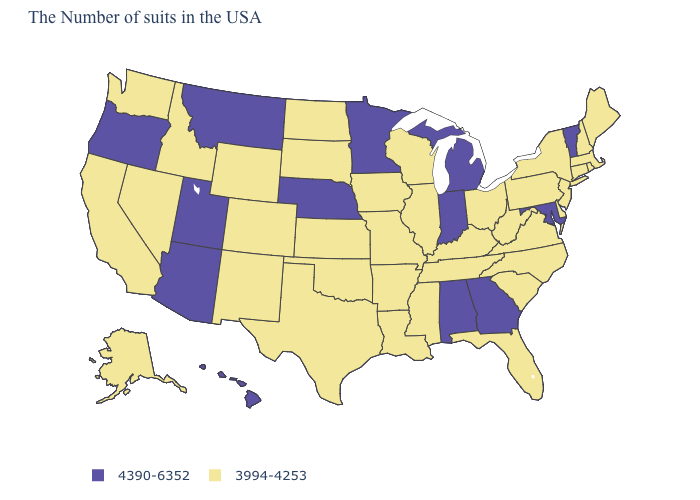Among the states that border Georgia , does Tennessee have the lowest value?
Answer briefly. Yes. Name the states that have a value in the range 3994-4253?
Be succinct. Maine, Massachusetts, Rhode Island, New Hampshire, Connecticut, New York, New Jersey, Delaware, Pennsylvania, Virginia, North Carolina, South Carolina, West Virginia, Ohio, Florida, Kentucky, Tennessee, Wisconsin, Illinois, Mississippi, Louisiana, Missouri, Arkansas, Iowa, Kansas, Oklahoma, Texas, South Dakota, North Dakota, Wyoming, Colorado, New Mexico, Idaho, Nevada, California, Washington, Alaska. What is the value of Delaware?
Give a very brief answer. 3994-4253. What is the value of Delaware?
Give a very brief answer. 3994-4253. Does Delaware have a lower value than New Jersey?
Write a very short answer. No. What is the value of Alaska?
Be succinct. 3994-4253. What is the value of Missouri?
Short answer required. 3994-4253. How many symbols are there in the legend?
Quick response, please. 2. Among the states that border New York , which have the highest value?
Give a very brief answer. Vermont. Name the states that have a value in the range 3994-4253?
Quick response, please. Maine, Massachusetts, Rhode Island, New Hampshire, Connecticut, New York, New Jersey, Delaware, Pennsylvania, Virginia, North Carolina, South Carolina, West Virginia, Ohio, Florida, Kentucky, Tennessee, Wisconsin, Illinois, Mississippi, Louisiana, Missouri, Arkansas, Iowa, Kansas, Oklahoma, Texas, South Dakota, North Dakota, Wyoming, Colorado, New Mexico, Idaho, Nevada, California, Washington, Alaska. Name the states that have a value in the range 4390-6352?
Concise answer only. Vermont, Maryland, Georgia, Michigan, Indiana, Alabama, Minnesota, Nebraska, Utah, Montana, Arizona, Oregon, Hawaii. Name the states that have a value in the range 4390-6352?
Quick response, please. Vermont, Maryland, Georgia, Michigan, Indiana, Alabama, Minnesota, Nebraska, Utah, Montana, Arizona, Oregon, Hawaii. Does Washington have a lower value than Utah?
Quick response, please. Yes. What is the value of Alaska?
Short answer required. 3994-4253. Name the states that have a value in the range 3994-4253?
Write a very short answer. Maine, Massachusetts, Rhode Island, New Hampshire, Connecticut, New York, New Jersey, Delaware, Pennsylvania, Virginia, North Carolina, South Carolina, West Virginia, Ohio, Florida, Kentucky, Tennessee, Wisconsin, Illinois, Mississippi, Louisiana, Missouri, Arkansas, Iowa, Kansas, Oklahoma, Texas, South Dakota, North Dakota, Wyoming, Colorado, New Mexico, Idaho, Nevada, California, Washington, Alaska. 